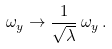Convert formula to latex. <formula><loc_0><loc_0><loc_500><loc_500>\omega _ { y } \rightarrow \frac { 1 } { \sqrt { \lambda } } \, \omega _ { y } \, .</formula> 